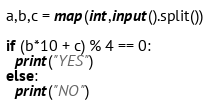Convert code to text. <code><loc_0><loc_0><loc_500><loc_500><_Python_>a,b,c = map(int,input().split())

if (b*10 + c) % 4 == 0:
  print("YES")
else:
  print("NO")</code> 